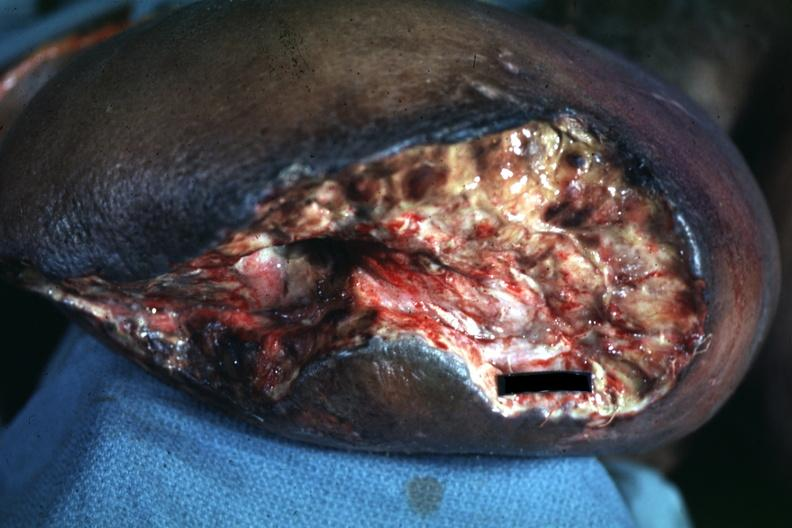does thyroid appear to be mid thigh?
Answer the question using a single word or phrase. No 